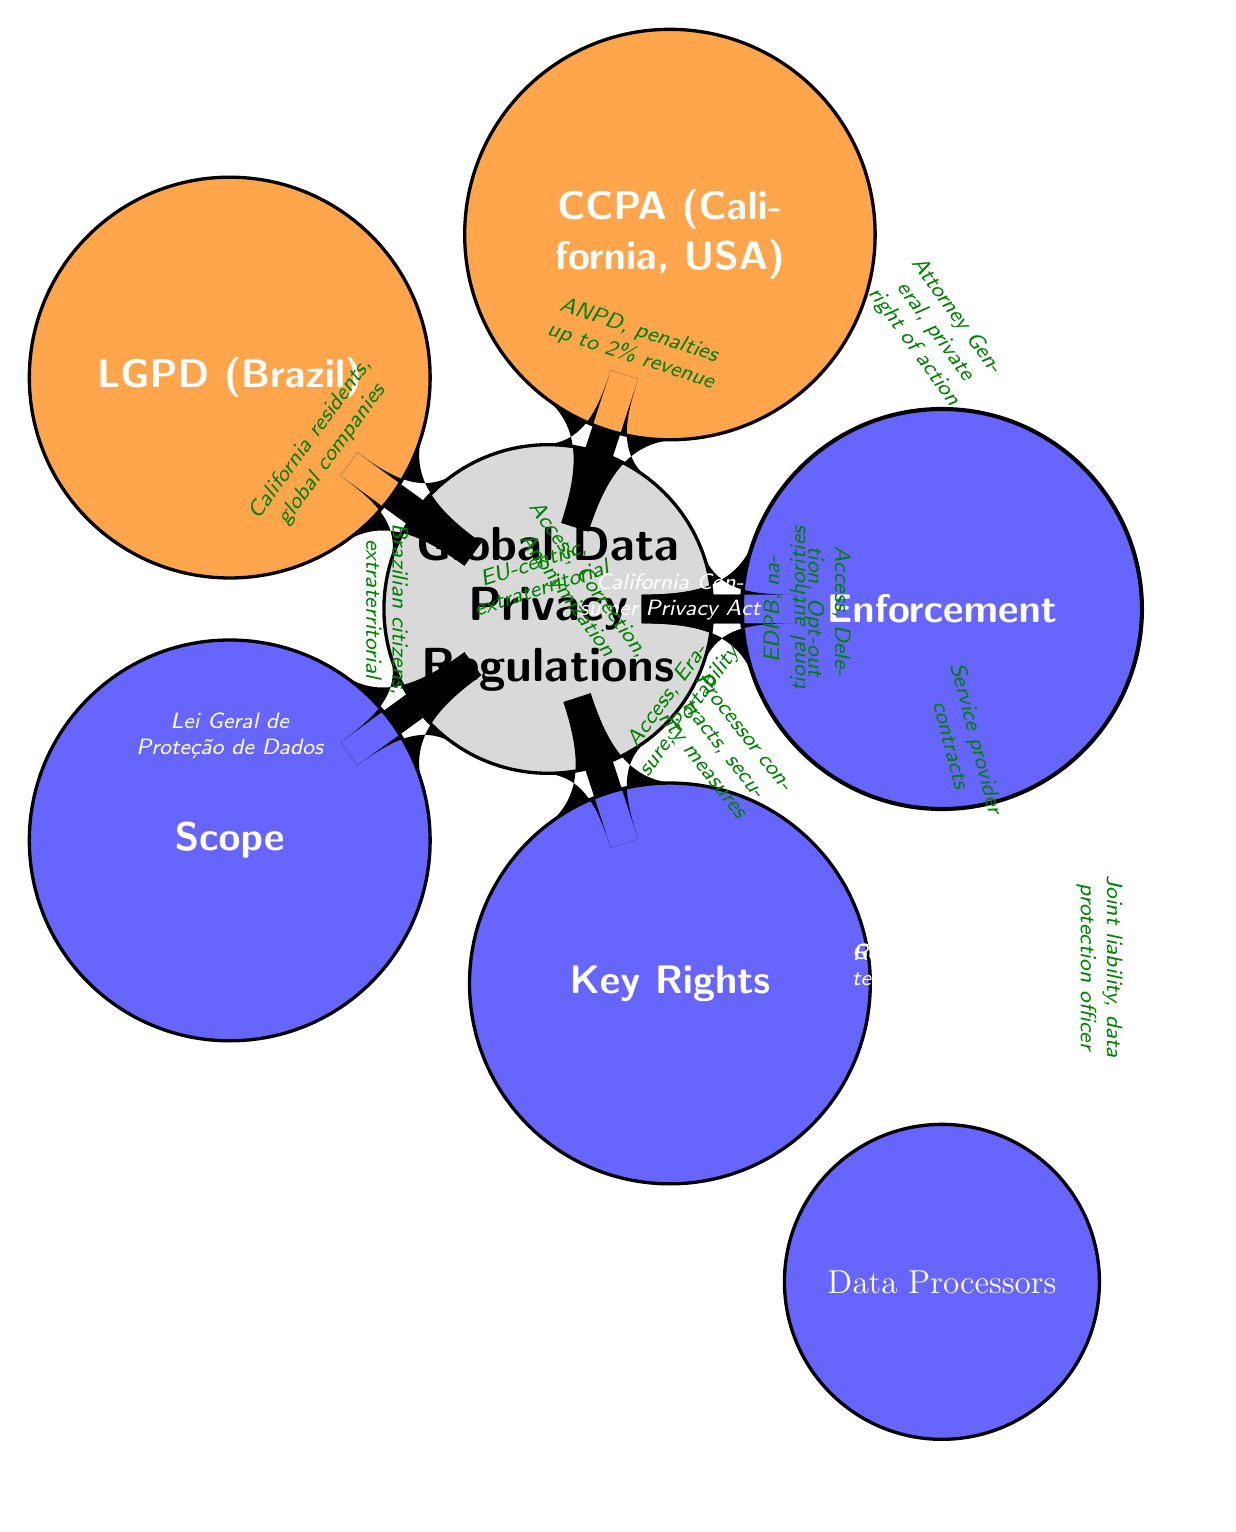What are the three main regulations represented in the diagram? The diagram directly lists three regulations: GDPR, CCPA, and LGPD, which are the main nodes branching out from the central concept of Global Data Privacy Regulations.
Answer: GDPR, CCPA, LGPD What is the geographical reach of GDPR? The diagram indicates that GDPR has an EU-centric scope with extraterritorial applicability, meaning it applies to any organization processing data of EU citizens, regardless of location.
Answer: EU-centric, extraterritorial What key rights does CCPA grant to individuals? According to the diagram, CCPA primarily provides the rights to Access, Deletion, and Opt-out, which are outlined as the key rights granted to California residents.
Answer: Access, Deletion, Opt-out What is the enforcement body for LGPD? Based on the diagram, LGPD is enforced by ANPD, which is its regulatory body, and penalties can go up to 2% of revenue.
Answer: ANPD, penalties up to 2% revenue Which regulation has the obligation of Data Processors noted in the diagram? The diagram connects obligations of Data Processors to GDPR, CCPA, and LGPD but specifies that GDPR emphasizes joint liability and the requirement for a data protection officer while others have different obligations.
Answer: GDPR How many aspects are compared across the regulations? The diagram presents three main aspects being compared: Scope, Key Rights, and Enforcement, which branch out from the central regulations. This indicates that there are three specific aspects highlighted.
Answer: 3 What is the annotation associated with the Enforcement node? The Enforcement node is annotated with information about the regulatory bodies and penalties related to each regulation, providing insight into how enforcement is structured within each jurisdiction.
Answer: Regulatory Bodies and Penalties What key right is unique to LGPD as compared to GDPR and CCPA? The diagram highlights that LGPD includes the right to Anonymization, which is not explicitly mentioned for GDPR and CCPA, making it unique among the compared regulations.
Answer: Anonymization 